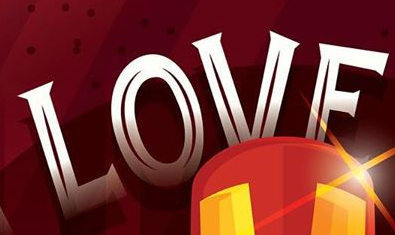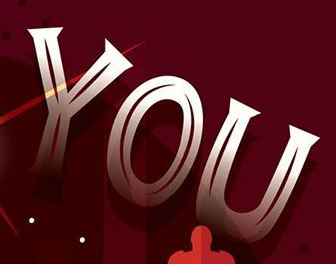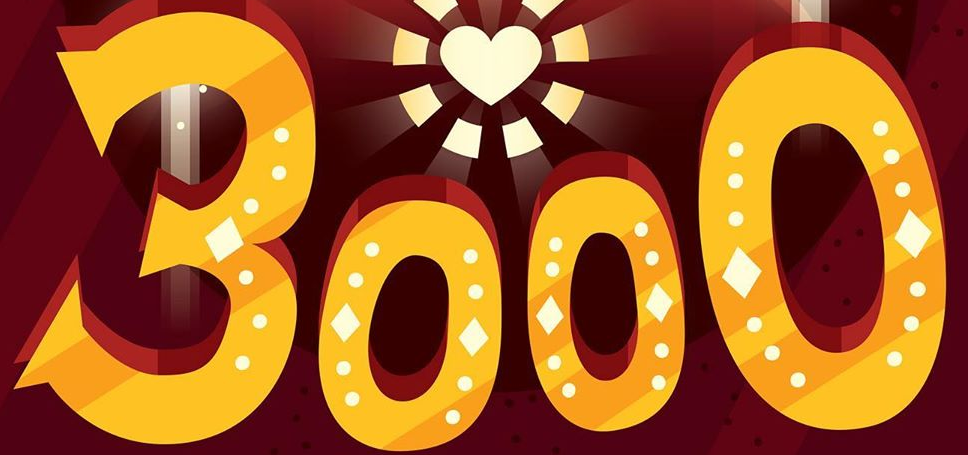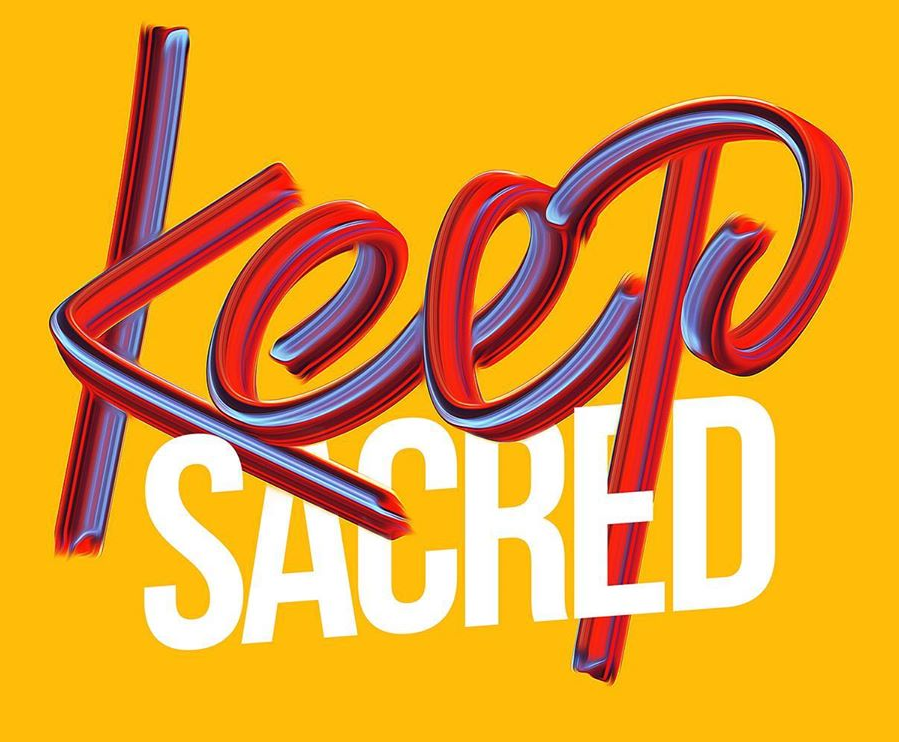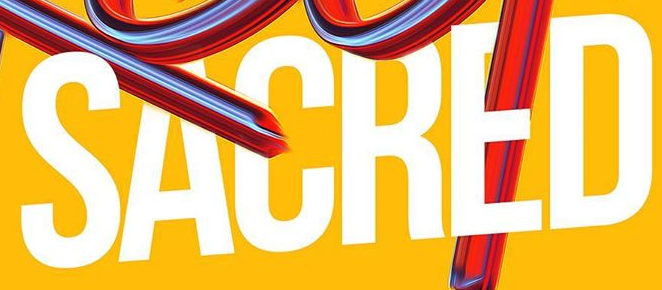Read the text content from these images in order, separated by a semicolon. LOVE; YOU; 3000; Keep; SACRED 